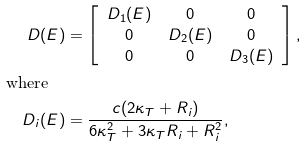<formula> <loc_0><loc_0><loc_500><loc_500>D ( E ) & = \left [ \begin{array} { c c c } D _ { 1 } ( E ) & 0 & 0 \\ 0 & D _ { 2 } ( E ) & 0 \\ 0 & 0 & D _ { 3 } ( E ) \end{array} \right ] , \\ \text {where} \quad & \\ D _ { i } ( E ) & = \frac { c ( 2 \kappa _ { T } + R _ { i } ) } { 6 \kappa _ { T } ^ { 2 } + 3 \kappa _ { T } R _ { i } + R _ { i } ^ { 2 } } ,</formula> 